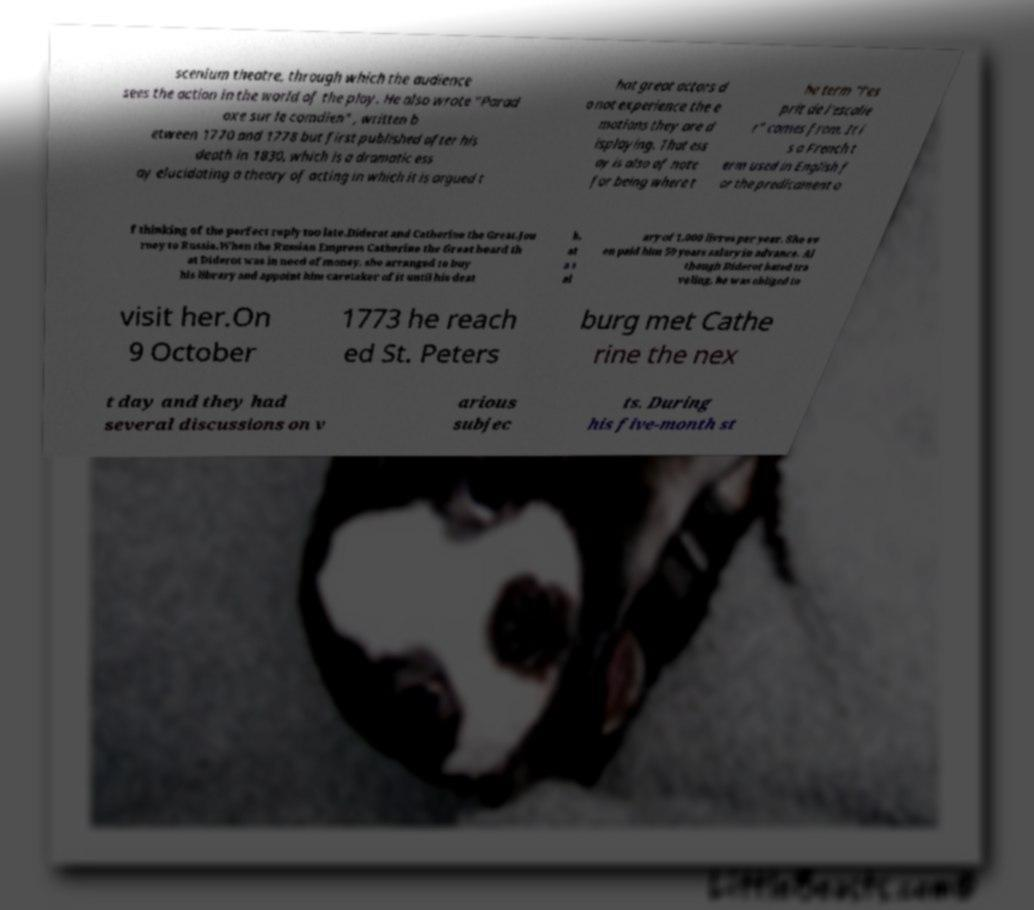Could you extract and type out the text from this image? scenium theatre, through which the audience sees the action in the world of the play. He also wrote "Parad oxe sur le comdien" , written b etween 1770 and 1778 but first published after his death in 1830, which is a dramatic ess ay elucidating a theory of acting in which it is argued t hat great actors d o not experience the e motions they are d isplaying. That ess ay is also of note for being where t he term "l'es prit de l'escalie r" comes from. It i s a French t erm used in English f or the predicament o f thinking of the perfect reply too late.Diderot and Catherine the Great.Jou rney to Russia.When the Russian Empress Catherine the Great heard th at Diderot was in need of money, she arranged to buy his library and appoint him caretaker of it until his deat h, at a s al ary of 1,000 livres per year. She ev en paid him 50 years salary in advance. Al though Diderot hated tra veling, he was obliged to visit her.On 9 October 1773 he reach ed St. Peters burg met Cathe rine the nex t day and they had several discussions on v arious subjec ts. During his five-month st 